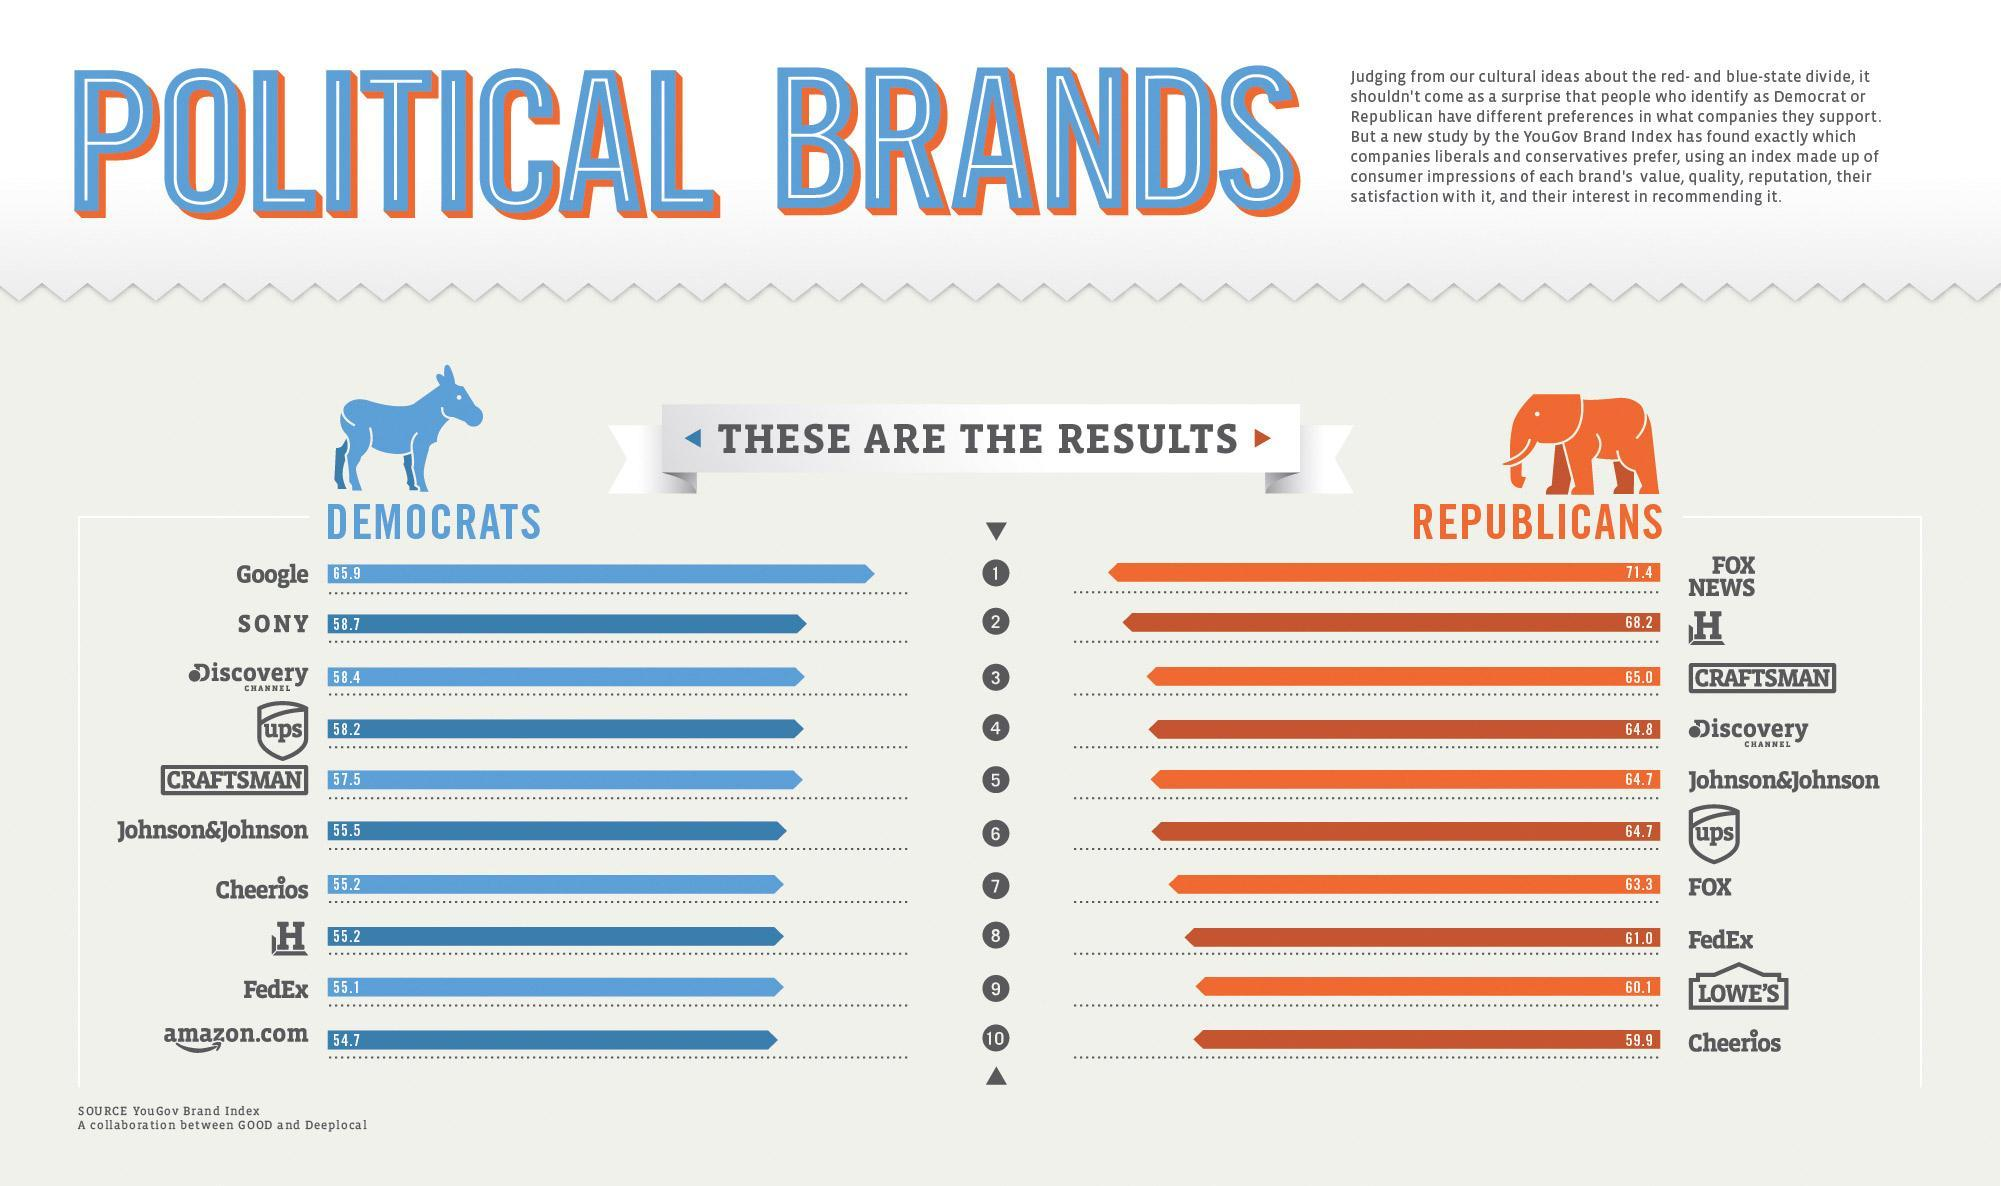Which brand is used by 58.2 Democrats and 64.7 Republicans?
Answer the question with a short phrase. ups Which is the cereal brand that more popular among the Democrats than the Republicans? Cheerios What is percentage of Democrats use Fedex? 55.1 Which news channel that is only used by the Republicans? FOX NEWS What percentage of Republicans like Johnson and Johnson and UPS brands? 64.7 